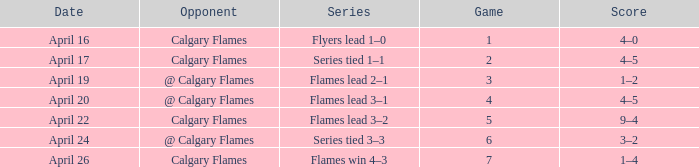Which Date has a Game smaller than 4, and an Opponent of calgary flames, and a Score of 4–5? April 17. 